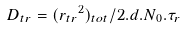<formula> <loc_0><loc_0><loc_500><loc_500>D _ { t r } = ( { r _ { t r } } ^ { 2 } ) _ { t o t } / { 2 . d . N _ { 0 } . \tau _ { r } }</formula> 